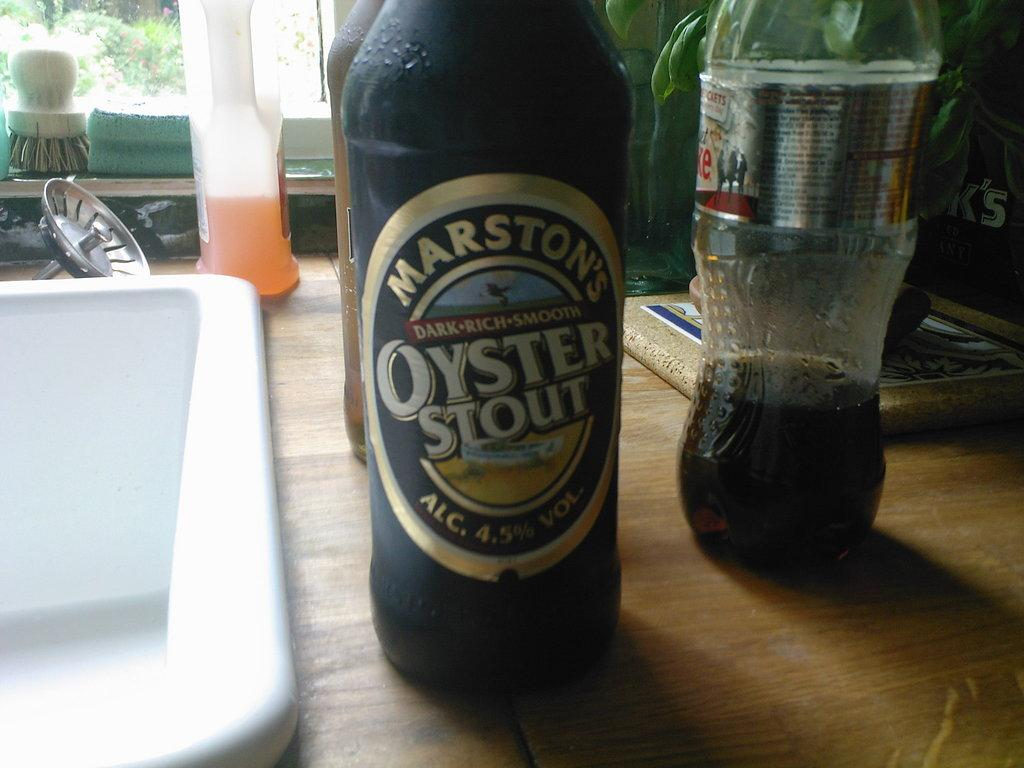<image>
Create a compact narrative representing the image presented. A bottle of Marston's Oyster Stout and a bottle of diet coke. 